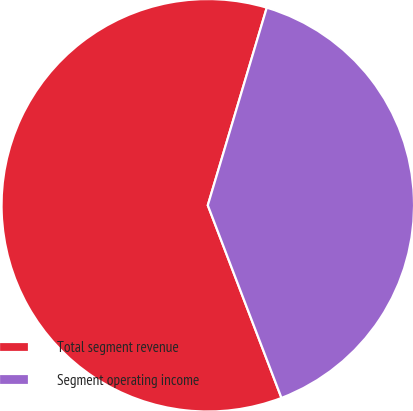Convert chart. <chart><loc_0><loc_0><loc_500><loc_500><pie_chart><fcel>Total segment revenue<fcel>Segment operating income<nl><fcel>60.43%<fcel>39.57%<nl></chart> 